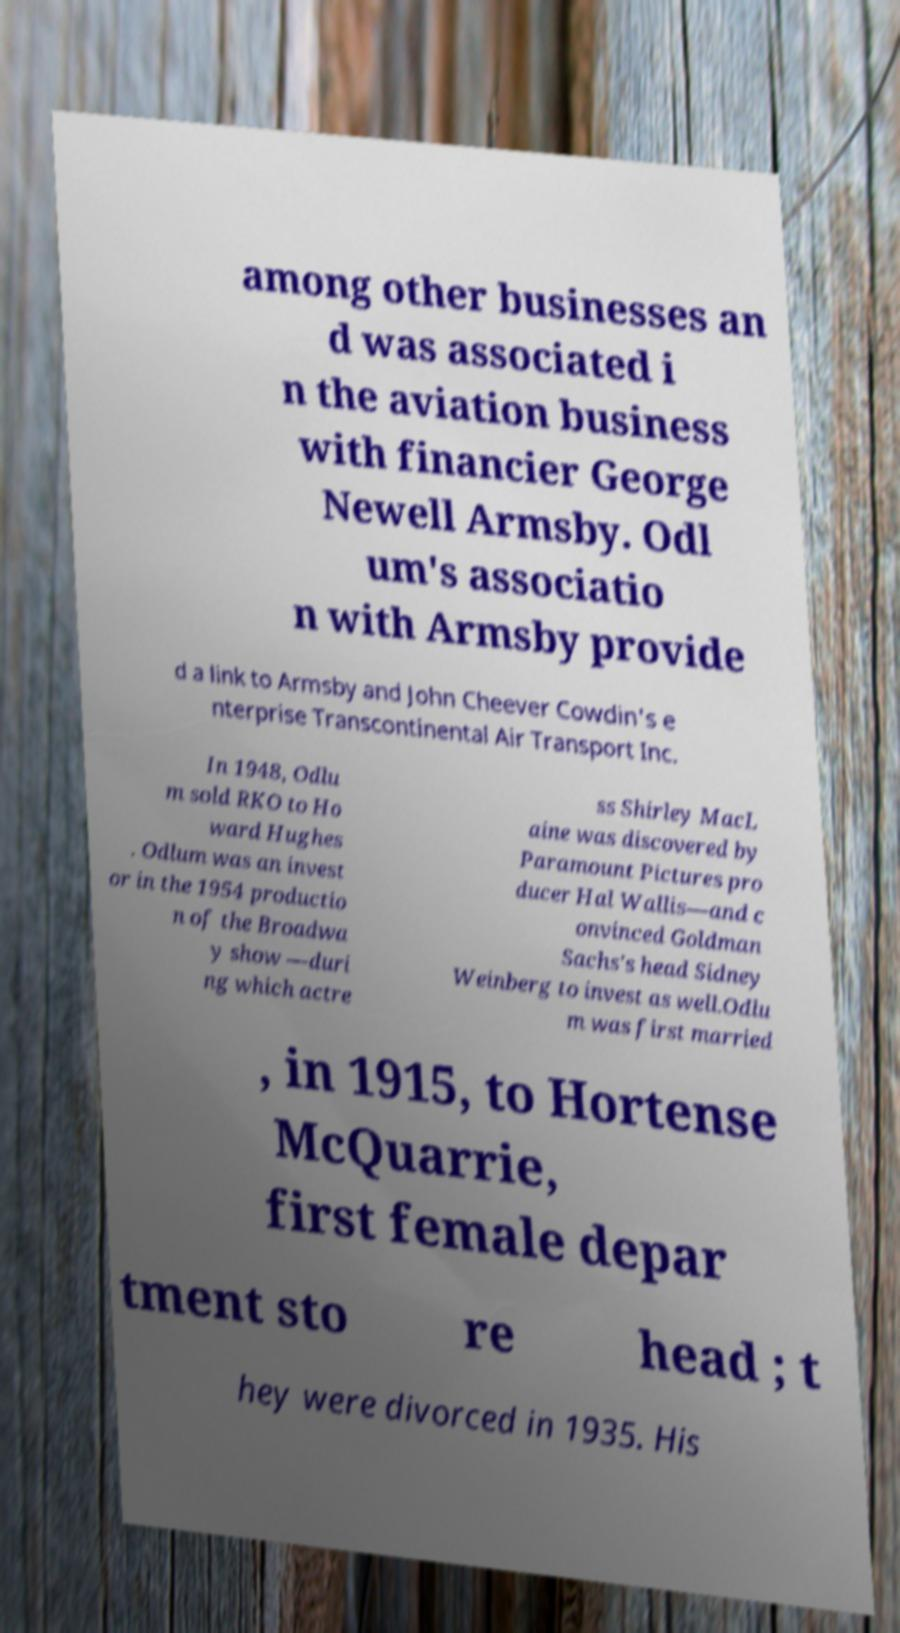Can you read and provide the text displayed in the image?This photo seems to have some interesting text. Can you extract and type it out for me? among other businesses an d was associated i n the aviation business with financier George Newell Armsby. Odl um's associatio n with Armsby provide d a link to Armsby and John Cheever Cowdin's e nterprise Transcontinental Air Transport Inc. In 1948, Odlu m sold RKO to Ho ward Hughes . Odlum was an invest or in the 1954 productio n of the Broadwa y show —duri ng which actre ss Shirley MacL aine was discovered by Paramount Pictures pro ducer Hal Wallis—and c onvinced Goldman Sachs's head Sidney Weinberg to invest as well.Odlu m was first married , in 1915, to Hortense McQuarrie, first female depar tment sto re head ; t hey were divorced in 1935. His 